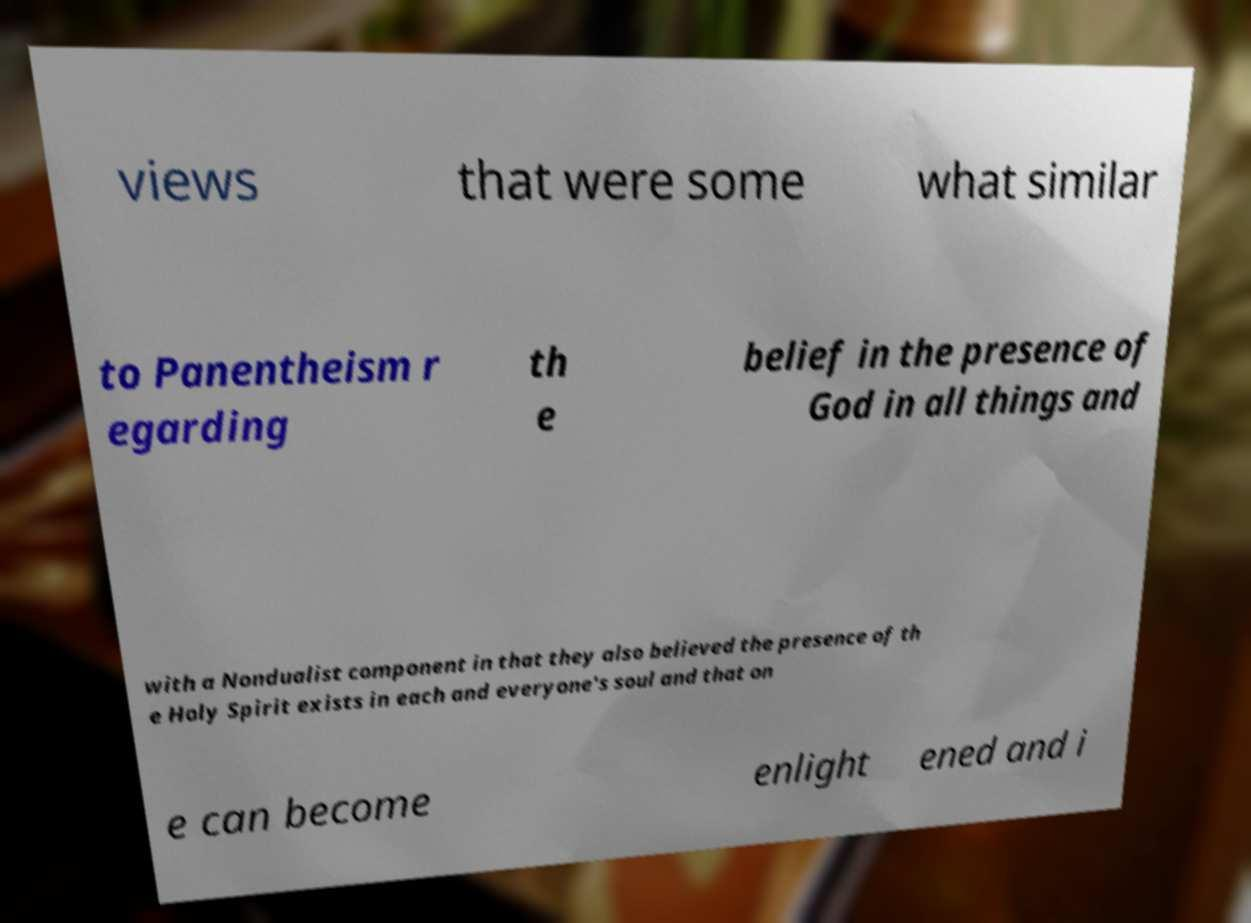Can you accurately transcribe the text from the provided image for me? views that were some what similar to Panentheism r egarding th e belief in the presence of God in all things and with a Nondualist component in that they also believed the presence of th e Holy Spirit exists in each and everyone's soul and that on e can become enlight ened and i 